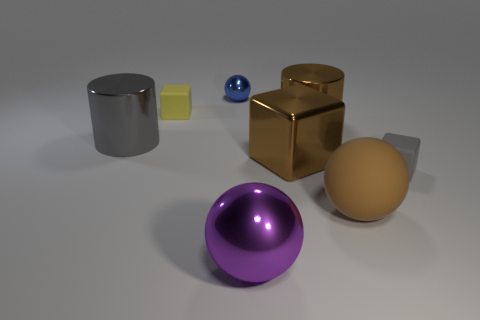Do the rubber object that is right of the brown ball and the large rubber thing have the same shape? No, they do not have the same shape. The rubber object to the right of the brown ball is a cylinder, while the large rubber item is a cube. 